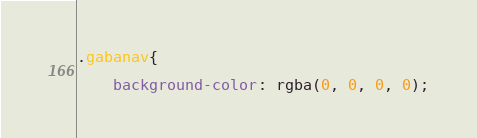Convert code to text. <code><loc_0><loc_0><loc_500><loc_500><_CSS_>.gabanav{
    
    background-color: rgba(0, 0, 0, 0);</code> 